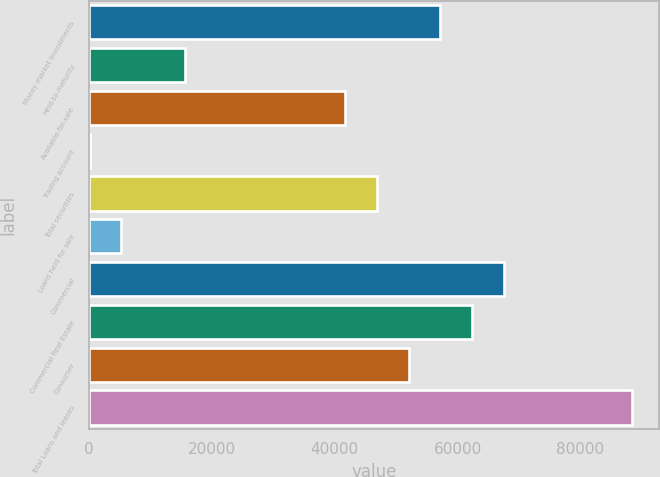Convert chart to OTSL. <chart><loc_0><loc_0><loc_500><loc_500><bar_chart><fcel>Money market investments<fcel>Held-to-maturity<fcel>Available-for-sale<fcel>Trading account<fcel>Total securities<fcel>Loans held for sale<fcel>Commercial<fcel>Commercial Real Estate<fcel>Consumer<fcel>Total Loans and leases<nl><fcel>57201.6<fcel>15644.8<fcel>41617.8<fcel>61<fcel>46812.4<fcel>5255.6<fcel>67590.8<fcel>62396.2<fcel>52007<fcel>88369.2<nl></chart> 